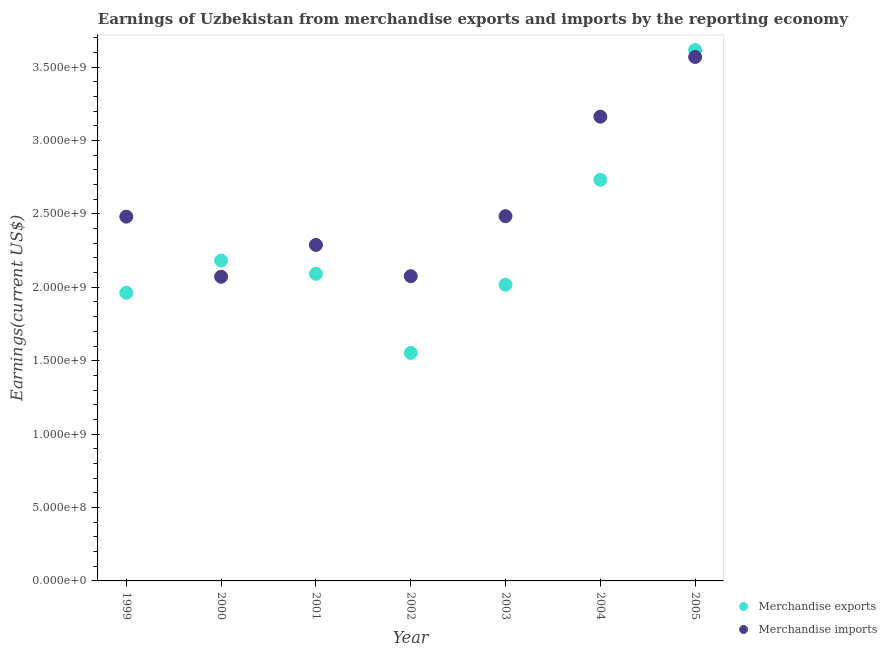What is the earnings from merchandise exports in 1999?
Give a very brief answer. 1.96e+09. Across all years, what is the maximum earnings from merchandise exports?
Provide a succinct answer. 3.62e+09. Across all years, what is the minimum earnings from merchandise exports?
Make the answer very short. 1.55e+09. In which year was the earnings from merchandise exports maximum?
Give a very brief answer. 2005. What is the total earnings from merchandise exports in the graph?
Provide a short and direct response. 1.62e+1. What is the difference between the earnings from merchandise exports in 2004 and that in 2005?
Your answer should be very brief. -8.84e+08. What is the difference between the earnings from merchandise imports in 2001 and the earnings from merchandise exports in 2005?
Keep it short and to the point. -1.33e+09. What is the average earnings from merchandise exports per year?
Give a very brief answer. 2.31e+09. In the year 2002, what is the difference between the earnings from merchandise exports and earnings from merchandise imports?
Ensure brevity in your answer.  -5.22e+08. What is the ratio of the earnings from merchandise imports in 2004 to that in 2005?
Your answer should be very brief. 0.89. Is the earnings from merchandise imports in 1999 less than that in 2001?
Offer a very short reply. No. Is the difference between the earnings from merchandise imports in 1999 and 2003 greater than the difference between the earnings from merchandise exports in 1999 and 2003?
Ensure brevity in your answer.  Yes. What is the difference between the highest and the second highest earnings from merchandise exports?
Offer a terse response. 8.84e+08. What is the difference between the highest and the lowest earnings from merchandise imports?
Provide a short and direct response. 1.50e+09. In how many years, is the earnings from merchandise exports greater than the average earnings from merchandise exports taken over all years?
Keep it short and to the point. 2. Is the sum of the earnings from merchandise imports in 2003 and 2005 greater than the maximum earnings from merchandise exports across all years?
Ensure brevity in your answer.  Yes. Is the earnings from merchandise imports strictly greater than the earnings from merchandise exports over the years?
Keep it short and to the point. No. How many dotlines are there?
Ensure brevity in your answer.  2. How many years are there in the graph?
Make the answer very short. 7. What is the difference between two consecutive major ticks on the Y-axis?
Your answer should be compact. 5.00e+08. How are the legend labels stacked?
Offer a very short reply. Vertical. What is the title of the graph?
Your response must be concise. Earnings of Uzbekistan from merchandise exports and imports by the reporting economy. What is the label or title of the Y-axis?
Provide a succinct answer. Earnings(current US$). What is the Earnings(current US$) in Merchandise exports in 1999?
Keep it short and to the point. 1.96e+09. What is the Earnings(current US$) of Merchandise imports in 1999?
Give a very brief answer. 2.48e+09. What is the Earnings(current US$) of Merchandise exports in 2000?
Give a very brief answer. 2.18e+09. What is the Earnings(current US$) of Merchandise imports in 2000?
Ensure brevity in your answer.  2.07e+09. What is the Earnings(current US$) in Merchandise exports in 2001?
Your answer should be very brief. 2.09e+09. What is the Earnings(current US$) in Merchandise imports in 2001?
Offer a very short reply. 2.29e+09. What is the Earnings(current US$) in Merchandise exports in 2002?
Make the answer very short. 1.55e+09. What is the Earnings(current US$) of Merchandise imports in 2002?
Offer a very short reply. 2.08e+09. What is the Earnings(current US$) of Merchandise exports in 2003?
Offer a terse response. 2.02e+09. What is the Earnings(current US$) of Merchandise imports in 2003?
Your answer should be very brief. 2.48e+09. What is the Earnings(current US$) of Merchandise exports in 2004?
Your answer should be compact. 2.73e+09. What is the Earnings(current US$) of Merchandise imports in 2004?
Your answer should be compact. 3.16e+09. What is the Earnings(current US$) of Merchandise exports in 2005?
Keep it short and to the point. 3.62e+09. What is the Earnings(current US$) of Merchandise imports in 2005?
Offer a terse response. 3.57e+09. Across all years, what is the maximum Earnings(current US$) of Merchandise exports?
Offer a terse response. 3.62e+09. Across all years, what is the maximum Earnings(current US$) in Merchandise imports?
Provide a succinct answer. 3.57e+09. Across all years, what is the minimum Earnings(current US$) of Merchandise exports?
Offer a terse response. 1.55e+09. Across all years, what is the minimum Earnings(current US$) in Merchandise imports?
Keep it short and to the point. 2.07e+09. What is the total Earnings(current US$) of Merchandise exports in the graph?
Offer a terse response. 1.62e+1. What is the total Earnings(current US$) in Merchandise imports in the graph?
Your response must be concise. 1.81e+1. What is the difference between the Earnings(current US$) in Merchandise exports in 1999 and that in 2000?
Your answer should be very brief. -2.19e+08. What is the difference between the Earnings(current US$) of Merchandise imports in 1999 and that in 2000?
Your response must be concise. 4.09e+08. What is the difference between the Earnings(current US$) in Merchandise exports in 1999 and that in 2001?
Give a very brief answer. -1.29e+08. What is the difference between the Earnings(current US$) in Merchandise imports in 1999 and that in 2001?
Provide a short and direct response. 1.93e+08. What is the difference between the Earnings(current US$) of Merchandise exports in 1999 and that in 2002?
Your answer should be very brief. 4.10e+08. What is the difference between the Earnings(current US$) of Merchandise imports in 1999 and that in 2002?
Provide a succinct answer. 4.06e+08. What is the difference between the Earnings(current US$) of Merchandise exports in 1999 and that in 2003?
Offer a very short reply. -5.49e+07. What is the difference between the Earnings(current US$) in Merchandise imports in 1999 and that in 2003?
Your answer should be compact. -3.25e+06. What is the difference between the Earnings(current US$) of Merchandise exports in 1999 and that in 2004?
Make the answer very short. -7.70e+08. What is the difference between the Earnings(current US$) of Merchandise imports in 1999 and that in 2004?
Your answer should be very brief. -6.81e+08. What is the difference between the Earnings(current US$) of Merchandise exports in 1999 and that in 2005?
Offer a terse response. -1.65e+09. What is the difference between the Earnings(current US$) of Merchandise imports in 1999 and that in 2005?
Give a very brief answer. -1.09e+09. What is the difference between the Earnings(current US$) in Merchandise exports in 2000 and that in 2001?
Your answer should be compact. 9.06e+07. What is the difference between the Earnings(current US$) in Merchandise imports in 2000 and that in 2001?
Offer a terse response. -2.17e+08. What is the difference between the Earnings(current US$) of Merchandise exports in 2000 and that in 2002?
Provide a succinct answer. 6.29e+08. What is the difference between the Earnings(current US$) of Merchandise imports in 2000 and that in 2002?
Ensure brevity in your answer.  -3.77e+06. What is the difference between the Earnings(current US$) of Merchandise exports in 2000 and that in 2003?
Provide a succinct answer. 1.65e+08. What is the difference between the Earnings(current US$) of Merchandise imports in 2000 and that in 2003?
Your response must be concise. -4.13e+08. What is the difference between the Earnings(current US$) in Merchandise exports in 2000 and that in 2004?
Provide a succinct answer. -5.50e+08. What is the difference between the Earnings(current US$) in Merchandise imports in 2000 and that in 2004?
Offer a very short reply. -1.09e+09. What is the difference between the Earnings(current US$) in Merchandise exports in 2000 and that in 2005?
Ensure brevity in your answer.  -1.43e+09. What is the difference between the Earnings(current US$) of Merchandise imports in 2000 and that in 2005?
Make the answer very short. -1.50e+09. What is the difference between the Earnings(current US$) of Merchandise exports in 2001 and that in 2002?
Offer a terse response. 5.38e+08. What is the difference between the Earnings(current US$) of Merchandise imports in 2001 and that in 2002?
Ensure brevity in your answer.  2.13e+08. What is the difference between the Earnings(current US$) in Merchandise exports in 2001 and that in 2003?
Your answer should be very brief. 7.39e+07. What is the difference between the Earnings(current US$) of Merchandise imports in 2001 and that in 2003?
Your answer should be compact. -1.96e+08. What is the difference between the Earnings(current US$) in Merchandise exports in 2001 and that in 2004?
Your response must be concise. -6.41e+08. What is the difference between the Earnings(current US$) in Merchandise imports in 2001 and that in 2004?
Provide a succinct answer. -8.74e+08. What is the difference between the Earnings(current US$) of Merchandise exports in 2001 and that in 2005?
Your answer should be compact. -1.52e+09. What is the difference between the Earnings(current US$) of Merchandise imports in 2001 and that in 2005?
Your answer should be compact. -1.28e+09. What is the difference between the Earnings(current US$) in Merchandise exports in 2002 and that in 2003?
Make the answer very short. -4.64e+08. What is the difference between the Earnings(current US$) of Merchandise imports in 2002 and that in 2003?
Give a very brief answer. -4.09e+08. What is the difference between the Earnings(current US$) of Merchandise exports in 2002 and that in 2004?
Offer a very short reply. -1.18e+09. What is the difference between the Earnings(current US$) of Merchandise imports in 2002 and that in 2004?
Keep it short and to the point. -1.09e+09. What is the difference between the Earnings(current US$) of Merchandise exports in 2002 and that in 2005?
Provide a succinct answer. -2.06e+09. What is the difference between the Earnings(current US$) in Merchandise imports in 2002 and that in 2005?
Provide a succinct answer. -1.49e+09. What is the difference between the Earnings(current US$) in Merchandise exports in 2003 and that in 2004?
Give a very brief answer. -7.15e+08. What is the difference between the Earnings(current US$) in Merchandise imports in 2003 and that in 2004?
Give a very brief answer. -6.78e+08. What is the difference between the Earnings(current US$) of Merchandise exports in 2003 and that in 2005?
Give a very brief answer. -1.60e+09. What is the difference between the Earnings(current US$) in Merchandise imports in 2003 and that in 2005?
Your response must be concise. -1.08e+09. What is the difference between the Earnings(current US$) in Merchandise exports in 2004 and that in 2005?
Give a very brief answer. -8.84e+08. What is the difference between the Earnings(current US$) in Merchandise imports in 2004 and that in 2005?
Provide a short and direct response. -4.07e+08. What is the difference between the Earnings(current US$) in Merchandise exports in 1999 and the Earnings(current US$) in Merchandise imports in 2000?
Provide a succinct answer. -1.09e+08. What is the difference between the Earnings(current US$) of Merchandise exports in 1999 and the Earnings(current US$) of Merchandise imports in 2001?
Ensure brevity in your answer.  -3.26e+08. What is the difference between the Earnings(current US$) of Merchandise exports in 1999 and the Earnings(current US$) of Merchandise imports in 2002?
Give a very brief answer. -1.13e+08. What is the difference between the Earnings(current US$) of Merchandise exports in 1999 and the Earnings(current US$) of Merchandise imports in 2003?
Offer a very short reply. -5.22e+08. What is the difference between the Earnings(current US$) in Merchandise exports in 1999 and the Earnings(current US$) in Merchandise imports in 2004?
Provide a succinct answer. -1.20e+09. What is the difference between the Earnings(current US$) of Merchandise exports in 1999 and the Earnings(current US$) of Merchandise imports in 2005?
Give a very brief answer. -1.61e+09. What is the difference between the Earnings(current US$) of Merchandise exports in 2000 and the Earnings(current US$) of Merchandise imports in 2001?
Your response must be concise. -1.06e+08. What is the difference between the Earnings(current US$) in Merchandise exports in 2000 and the Earnings(current US$) in Merchandise imports in 2002?
Give a very brief answer. 1.07e+08. What is the difference between the Earnings(current US$) of Merchandise exports in 2000 and the Earnings(current US$) of Merchandise imports in 2003?
Your answer should be compact. -3.02e+08. What is the difference between the Earnings(current US$) of Merchandise exports in 2000 and the Earnings(current US$) of Merchandise imports in 2004?
Your answer should be very brief. -9.80e+08. What is the difference between the Earnings(current US$) of Merchandise exports in 2000 and the Earnings(current US$) of Merchandise imports in 2005?
Provide a succinct answer. -1.39e+09. What is the difference between the Earnings(current US$) of Merchandise exports in 2001 and the Earnings(current US$) of Merchandise imports in 2002?
Your answer should be very brief. 1.59e+07. What is the difference between the Earnings(current US$) in Merchandise exports in 2001 and the Earnings(current US$) in Merchandise imports in 2003?
Provide a short and direct response. -3.93e+08. What is the difference between the Earnings(current US$) of Merchandise exports in 2001 and the Earnings(current US$) of Merchandise imports in 2004?
Ensure brevity in your answer.  -1.07e+09. What is the difference between the Earnings(current US$) in Merchandise exports in 2001 and the Earnings(current US$) in Merchandise imports in 2005?
Your answer should be compact. -1.48e+09. What is the difference between the Earnings(current US$) in Merchandise exports in 2002 and the Earnings(current US$) in Merchandise imports in 2003?
Ensure brevity in your answer.  -9.31e+08. What is the difference between the Earnings(current US$) of Merchandise exports in 2002 and the Earnings(current US$) of Merchandise imports in 2004?
Make the answer very short. -1.61e+09. What is the difference between the Earnings(current US$) in Merchandise exports in 2002 and the Earnings(current US$) in Merchandise imports in 2005?
Keep it short and to the point. -2.02e+09. What is the difference between the Earnings(current US$) in Merchandise exports in 2003 and the Earnings(current US$) in Merchandise imports in 2004?
Offer a very short reply. -1.14e+09. What is the difference between the Earnings(current US$) in Merchandise exports in 2003 and the Earnings(current US$) in Merchandise imports in 2005?
Keep it short and to the point. -1.55e+09. What is the difference between the Earnings(current US$) in Merchandise exports in 2004 and the Earnings(current US$) in Merchandise imports in 2005?
Your response must be concise. -8.36e+08. What is the average Earnings(current US$) of Merchandise exports per year?
Your response must be concise. 2.31e+09. What is the average Earnings(current US$) in Merchandise imports per year?
Give a very brief answer. 2.59e+09. In the year 1999, what is the difference between the Earnings(current US$) in Merchandise exports and Earnings(current US$) in Merchandise imports?
Make the answer very short. -5.18e+08. In the year 2000, what is the difference between the Earnings(current US$) of Merchandise exports and Earnings(current US$) of Merchandise imports?
Make the answer very short. 1.10e+08. In the year 2001, what is the difference between the Earnings(current US$) in Merchandise exports and Earnings(current US$) in Merchandise imports?
Make the answer very short. -1.97e+08. In the year 2002, what is the difference between the Earnings(current US$) of Merchandise exports and Earnings(current US$) of Merchandise imports?
Give a very brief answer. -5.22e+08. In the year 2003, what is the difference between the Earnings(current US$) in Merchandise exports and Earnings(current US$) in Merchandise imports?
Your answer should be very brief. -4.67e+08. In the year 2004, what is the difference between the Earnings(current US$) of Merchandise exports and Earnings(current US$) of Merchandise imports?
Your answer should be very brief. -4.30e+08. In the year 2005, what is the difference between the Earnings(current US$) of Merchandise exports and Earnings(current US$) of Merchandise imports?
Make the answer very short. 4.74e+07. What is the ratio of the Earnings(current US$) of Merchandise exports in 1999 to that in 2000?
Offer a very short reply. 0.9. What is the ratio of the Earnings(current US$) in Merchandise imports in 1999 to that in 2000?
Provide a short and direct response. 1.2. What is the ratio of the Earnings(current US$) in Merchandise exports in 1999 to that in 2001?
Provide a short and direct response. 0.94. What is the ratio of the Earnings(current US$) of Merchandise imports in 1999 to that in 2001?
Provide a succinct answer. 1.08. What is the ratio of the Earnings(current US$) of Merchandise exports in 1999 to that in 2002?
Offer a very short reply. 1.26. What is the ratio of the Earnings(current US$) in Merchandise imports in 1999 to that in 2002?
Offer a very short reply. 1.2. What is the ratio of the Earnings(current US$) in Merchandise exports in 1999 to that in 2003?
Keep it short and to the point. 0.97. What is the ratio of the Earnings(current US$) in Merchandise imports in 1999 to that in 2003?
Offer a very short reply. 1. What is the ratio of the Earnings(current US$) of Merchandise exports in 1999 to that in 2004?
Your answer should be very brief. 0.72. What is the ratio of the Earnings(current US$) of Merchandise imports in 1999 to that in 2004?
Make the answer very short. 0.78. What is the ratio of the Earnings(current US$) in Merchandise exports in 1999 to that in 2005?
Provide a succinct answer. 0.54. What is the ratio of the Earnings(current US$) in Merchandise imports in 1999 to that in 2005?
Your answer should be compact. 0.7. What is the ratio of the Earnings(current US$) of Merchandise exports in 2000 to that in 2001?
Ensure brevity in your answer.  1.04. What is the ratio of the Earnings(current US$) of Merchandise imports in 2000 to that in 2001?
Your response must be concise. 0.91. What is the ratio of the Earnings(current US$) of Merchandise exports in 2000 to that in 2002?
Give a very brief answer. 1.4. What is the ratio of the Earnings(current US$) of Merchandise imports in 2000 to that in 2002?
Give a very brief answer. 1. What is the ratio of the Earnings(current US$) of Merchandise exports in 2000 to that in 2003?
Your response must be concise. 1.08. What is the ratio of the Earnings(current US$) of Merchandise imports in 2000 to that in 2003?
Your answer should be compact. 0.83. What is the ratio of the Earnings(current US$) in Merchandise exports in 2000 to that in 2004?
Keep it short and to the point. 0.8. What is the ratio of the Earnings(current US$) in Merchandise imports in 2000 to that in 2004?
Your answer should be very brief. 0.66. What is the ratio of the Earnings(current US$) in Merchandise exports in 2000 to that in 2005?
Your response must be concise. 0.6. What is the ratio of the Earnings(current US$) in Merchandise imports in 2000 to that in 2005?
Offer a terse response. 0.58. What is the ratio of the Earnings(current US$) of Merchandise exports in 2001 to that in 2002?
Ensure brevity in your answer.  1.35. What is the ratio of the Earnings(current US$) of Merchandise imports in 2001 to that in 2002?
Offer a terse response. 1.1. What is the ratio of the Earnings(current US$) of Merchandise exports in 2001 to that in 2003?
Offer a terse response. 1.04. What is the ratio of the Earnings(current US$) in Merchandise imports in 2001 to that in 2003?
Your response must be concise. 0.92. What is the ratio of the Earnings(current US$) of Merchandise exports in 2001 to that in 2004?
Offer a very short reply. 0.77. What is the ratio of the Earnings(current US$) of Merchandise imports in 2001 to that in 2004?
Provide a succinct answer. 0.72. What is the ratio of the Earnings(current US$) of Merchandise exports in 2001 to that in 2005?
Your answer should be very brief. 0.58. What is the ratio of the Earnings(current US$) of Merchandise imports in 2001 to that in 2005?
Ensure brevity in your answer.  0.64. What is the ratio of the Earnings(current US$) of Merchandise exports in 2002 to that in 2003?
Keep it short and to the point. 0.77. What is the ratio of the Earnings(current US$) in Merchandise imports in 2002 to that in 2003?
Keep it short and to the point. 0.84. What is the ratio of the Earnings(current US$) of Merchandise exports in 2002 to that in 2004?
Provide a short and direct response. 0.57. What is the ratio of the Earnings(current US$) of Merchandise imports in 2002 to that in 2004?
Ensure brevity in your answer.  0.66. What is the ratio of the Earnings(current US$) of Merchandise exports in 2002 to that in 2005?
Provide a short and direct response. 0.43. What is the ratio of the Earnings(current US$) of Merchandise imports in 2002 to that in 2005?
Ensure brevity in your answer.  0.58. What is the ratio of the Earnings(current US$) in Merchandise exports in 2003 to that in 2004?
Provide a short and direct response. 0.74. What is the ratio of the Earnings(current US$) of Merchandise imports in 2003 to that in 2004?
Your response must be concise. 0.79. What is the ratio of the Earnings(current US$) in Merchandise exports in 2003 to that in 2005?
Keep it short and to the point. 0.56. What is the ratio of the Earnings(current US$) of Merchandise imports in 2003 to that in 2005?
Your answer should be compact. 0.7. What is the ratio of the Earnings(current US$) of Merchandise exports in 2004 to that in 2005?
Your answer should be very brief. 0.76. What is the ratio of the Earnings(current US$) of Merchandise imports in 2004 to that in 2005?
Give a very brief answer. 0.89. What is the difference between the highest and the second highest Earnings(current US$) in Merchandise exports?
Your answer should be compact. 8.84e+08. What is the difference between the highest and the second highest Earnings(current US$) in Merchandise imports?
Offer a very short reply. 4.07e+08. What is the difference between the highest and the lowest Earnings(current US$) of Merchandise exports?
Your answer should be very brief. 2.06e+09. What is the difference between the highest and the lowest Earnings(current US$) in Merchandise imports?
Give a very brief answer. 1.50e+09. 